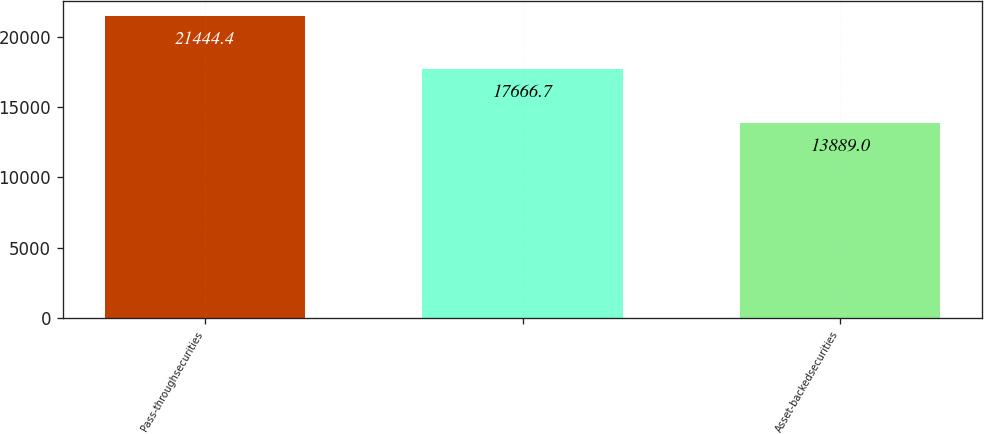Convert chart to OTSL. <chart><loc_0><loc_0><loc_500><loc_500><bar_chart><fcel>Pass-throughsecurities<fcel>Unnamed: 1<fcel>Asset-backedsecurities<nl><fcel>21444.4<fcel>17666.7<fcel>13889<nl></chart> 